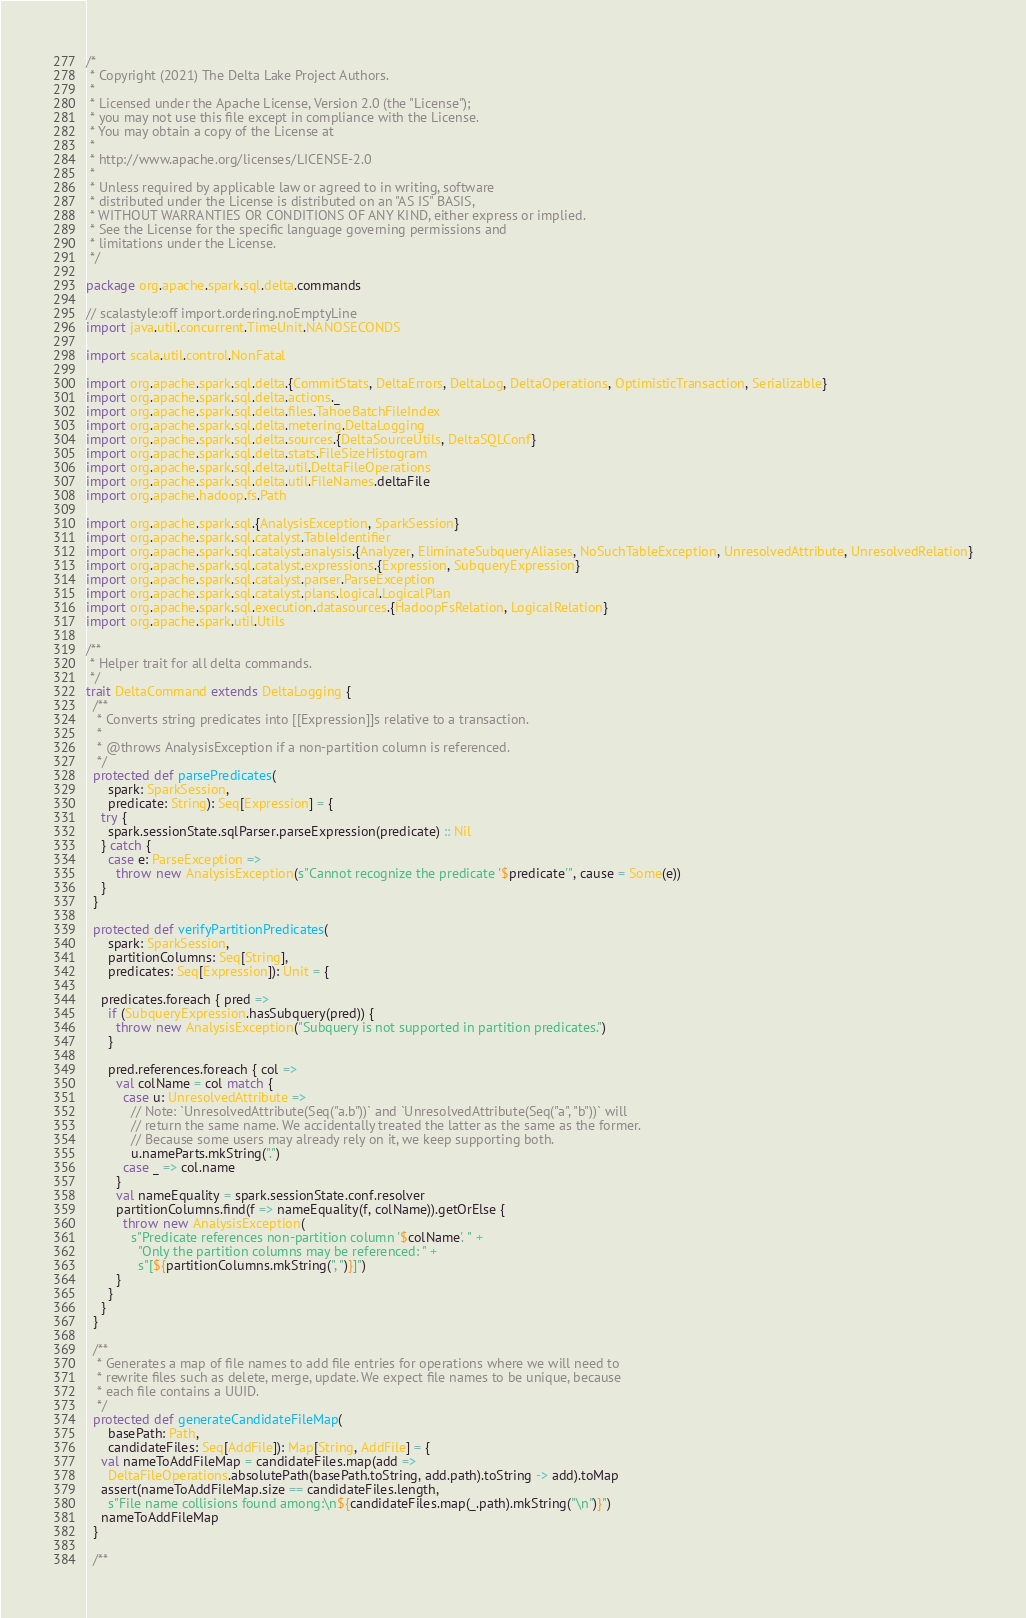<code> <loc_0><loc_0><loc_500><loc_500><_Scala_>/*
 * Copyright (2021) The Delta Lake Project Authors.
 *
 * Licensed under the Apache License, Version 2.0 (the "License");
 * you may not use this file except in compliance with the License.
 * You may obtain a copy of the License at
 *
 * http://www.apache.org/licenses/LICENSE-2.0
 *
 * Unless required by applicable law or agreed to in writing, software
 * distributed under the License is distributed on an "AS IS" BASIS,
 * WITHOUT WARRANTIES OR CONDITIONS OF ANY KIND, either express or implied.
 * See the License for the specific language governing permissions and
 * limitations under the License.
 */

package org.apache.spark.sql.delta.commands

// scalastyle:off import.ordering.noEmptyLine
import java.util.concurrent.TimeUnit.NANOSECONDS

import scala.util.control.NonFatal

import org.apache.spark.sql.delta.{CommitStats, DeltaErrors, DeltaLog, DeltaOperations, OptimisticTransaction, Serializable}
import org.apache.spark.sql.delta.actions._
import org.apache.spark.sql.delta.files.TahoeBatchFileIndex
import org.apache.spark.sql.delta.metering.DeltaLogging
import org.apache.spark.sql.delta.sources.{DeltaSourceUtils, DeltaSQLConf}
import org.apache.spark.sql.delta.stats.FileSizeHistogram
import org.apache.spark.sql.delta.util.DeltaFileOperations
import org.apache.spark.sql.delta.util.FileNames.deltaFile
import org.apache.hadoop.fs.Path

import org.apache.spark.sql.{AnalysisException, SparkSession}
import org.apache.spark.sql.catalyst.TableIdentifier
import org.apache.spark.sql.catalyst.analysis.{Analyzer, EliminateSubqueryAliases, NoSuchTableException, UnresolvedAttribute, UnresolvedRelation}
import org.apache.spark.sql.catalyst.expressions.{Expression, SubqueryExpression}
import org.apache.spark.sql.catalyst.parser.ParseException
import org.apache.spark.sql.catalyst.plans.logical.LogicalPlan
import org.apache.spark.sql.execution.datasources.{HadoopFsRelation, LogicalRelation}
import org.apache.spark.util.Utils

/**
 * Helper trait for all delta commands.
 */
trait DeltaCommand extends DeltaLogging {
  /**
   * Converts string predicates into [[Expression]]s relative to a transaction.
   *
   * @throws AnalysisException if a non-partition column is referenced.
   */
  protected def parsePredicates(
      spark: SparkSession,
      predicate: String): Seq[Expression] = {
    try {
      spark.sessionState.sqlParser.parseExpression(predicate) :: Nil
    } catch {
      case e: ParseException =>
        throw new AnalysisException(s"Cannot recognize the predicate '$predicate'", cause = Some(e))
    }
  }

  protected def verifyPartitionPredicates(
      spark: SparkSession,
      partitionColumns: Seq[String],
      predicates: Seq[Expression]): Unit = {

    predicates.foreach { pred =>
      if (SubqueryExpression.hasSubquery(pred)) {
        throw new AnalysisException("Subquery is not supported in partition predicates.")
      }

      pred.references.foreach { col =>
        val colName = col match {
          case u: UnresolvedAttribute =>
            // Note: `UnresolvedAttribute(Seq("a.b"))` and `UnresolvedAttribute(Seq("a", "b"))` will
            // return the same name. We accidentally treated the latter as the same as the former.
            // Because some users may already rely on it, we keep supporting both.
            u.nameParts.mkString(".")
          case _ => col.name
        }
        val nameEquality = spark.sessionState.conf.resolver
        partitionColumns.find(f => nameEquality(f, colName)).getOrElse {
          throw new AnalysisException(
            s"Predicate references non-partition column '$colName'. " +
              "Only the partition columns may be referenced: " +
              s"[${partitionColumns.mkString(", ")}]")
        }
      }
    }
  }

  /**
   * Generates a map of file names to add file entries for operations where we will need to
   * rewrite files such as delete, merge, update. We expect file names to be unique, because
   * each file contains a UUID.
   */
  protected def generateCandidateFileMap(
      basePath: Path,
      candidateFiles: Seq[AddFile]): Map[String, AddFile] = {
    val nameToAddFileMap = candidateFiles.map(add =>
      DeltaFileOperations.absolutePath(basePath.toString, add.path).toString -> add).toMap
    assert(nameToAddFileMap.size == candidateFiles.length,
      s"File name collisions found among:\n${candidateFiles.map(_.path).mkString("\n")}")
    nameToAddFileMap
  }

  /**</code> 